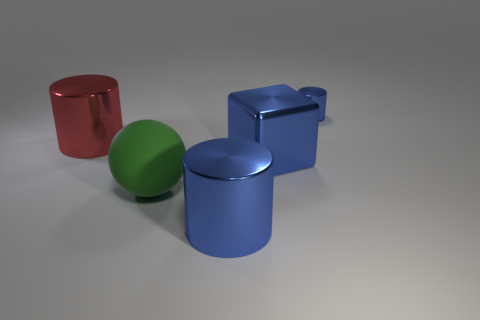How many blue cylinders must be subtracted to get 1 blue cylinders? 1 Subtract all tiny metal cylinders. How many cylinders are left? 2 Add 3 cylinders. How many objects exist? 8 Subtract all brown cylinders. Subtract all gray spheres. How many cylinders are left? 3 Subtract all large cubes. Subtract all big metal objects. How many objects are left? 1 Add 5 blue things. How many blue things are left? 8 Add 1 metal blocks. How many metal blocks exist? 2 Subtract 0 red cubes. How many objects are left? 5 Subtract all spheres. How many objects are left? 4 